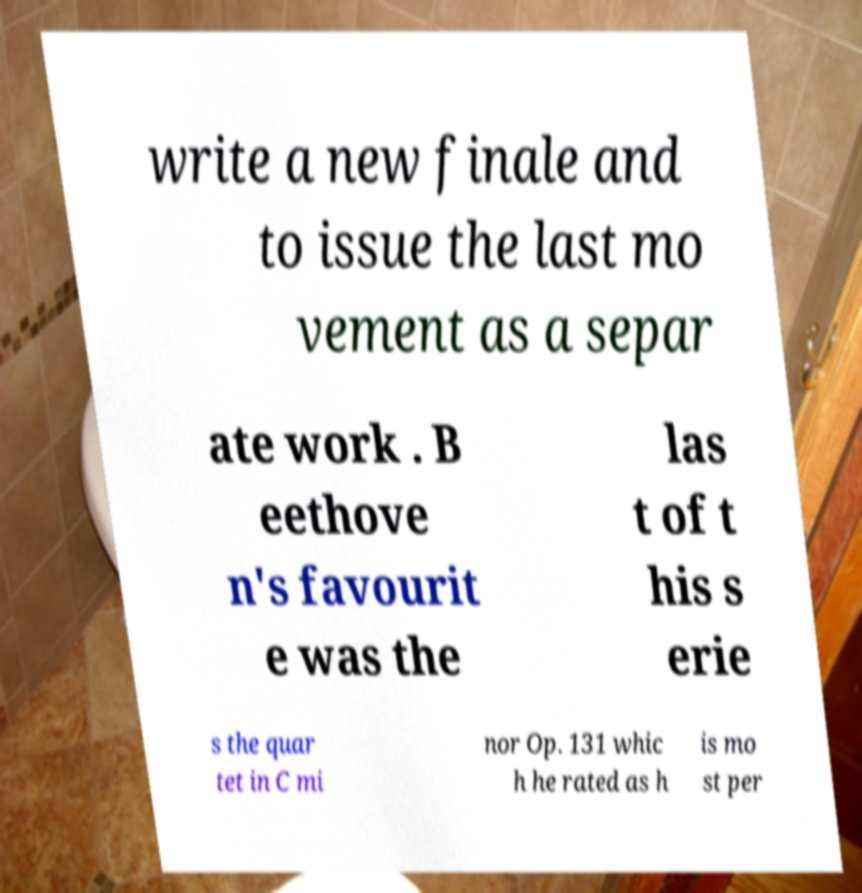Can you read and provide the text displayed in the image?This photo seems to have some interesting text. Can you extract and type it out for me? write a new finale and to issue the last mo vement as a separ ate work . B eethove n's favourit e was the las t of t his s erie s the quar tet in C mi nor Op. 131 whic h he rated as h is mo st per 